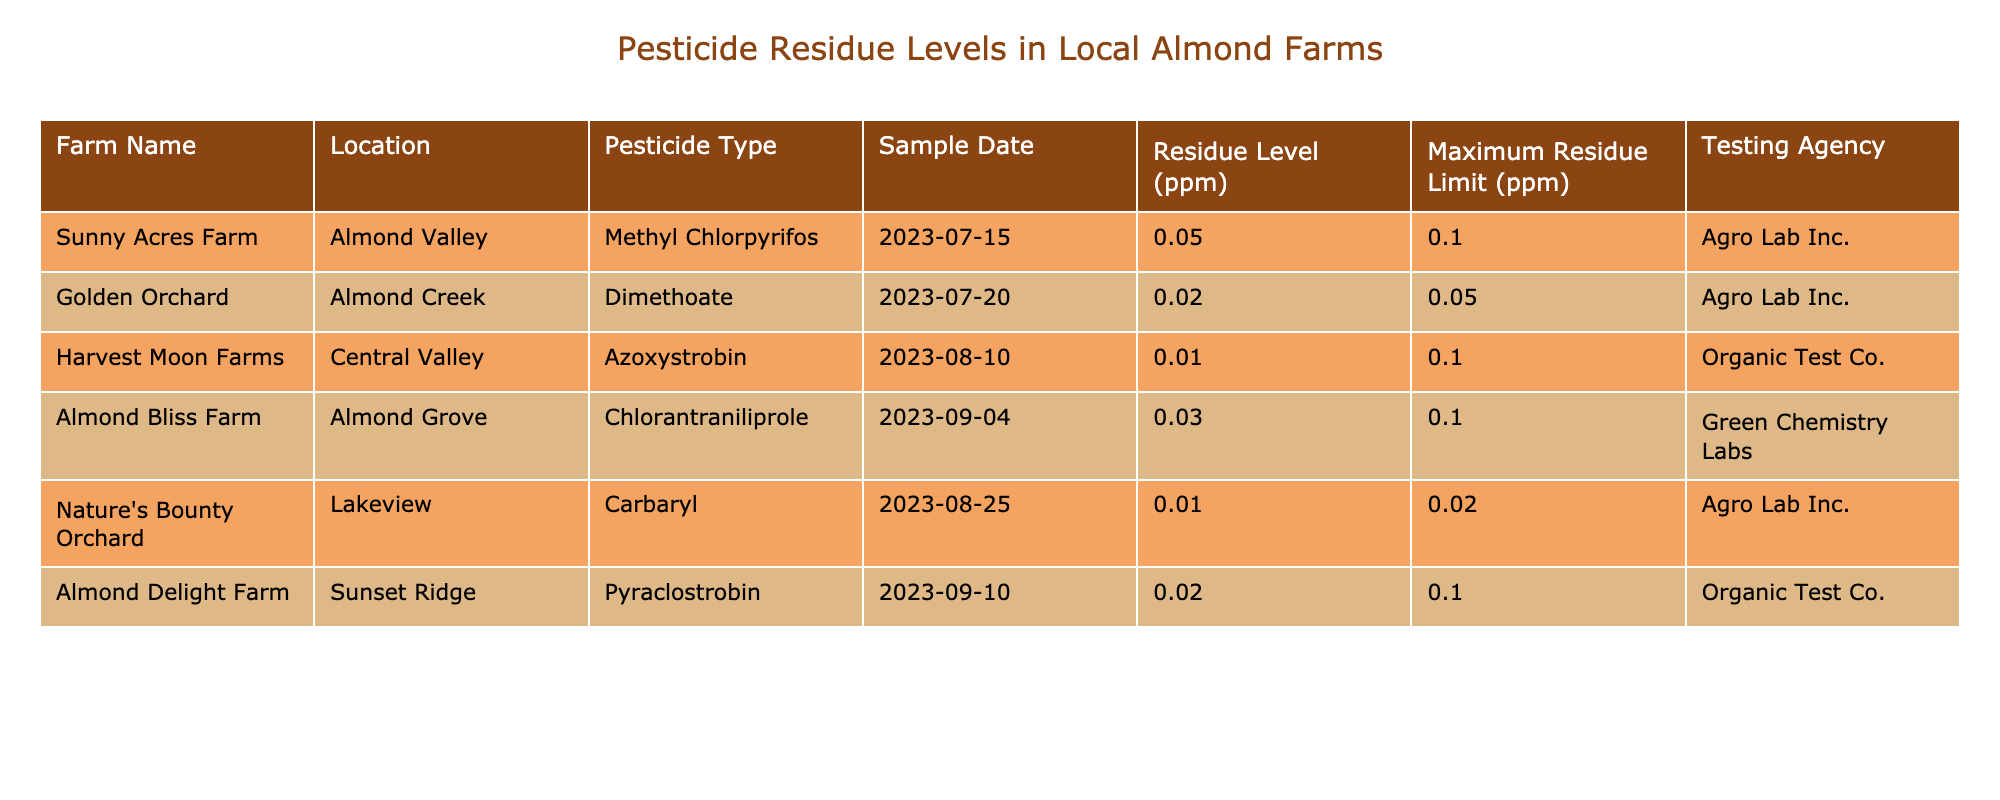What is the maximum residue limit for Dimethoate? Looking at the entry for Dimethoate under Pesticide Type, the Maximum Residue Limit (ppm) is listed as 0.05.
Answer: 0.05 Which farm has the highest pesticide residue level? Comparing all the residue levels listed in the table, Sunny Acres Farm has the highest level at 0.05 ppm.
Answer: Sunny Acres Farm Is the residue level at Nature's Bounty Orchard above the maximum residue limit? The residue level for Nature's Bounty Orchard is 0.01 ppm, which is below the Maximum Residue Limit of 0.02 ppm. Therefore, it is not above the limit.
Answer: No What is the average pesticide residue level across all the farms? Adding the residue levels: 0.05 + 0.02 + 0.01 + 0.03 + 0.01 + 0.02 = 0.14 ppm. There are 6 data points, so the average is 0.14/6 = 0.0233 ppm.
Answer: 0.0233 Did any farms exceed the maximum residue limits? By comparing each farm's residue level to its Maximum Residue Limit, all farms are below their respective limits, so none have exceeded the limits.
Answer: No What is the residue level of Chlorantraniliprole at Almond Bliss Farm? Referring to the entry for Almond Bliss Farm, the residue level for Chlorantraniliprole is 0.03 ppm.
Answer: 0.03 How many farms tested for pesticide residues in August 2023? There are two farms that tested in August 2023: Harvest Moon Farms on August 10 and Nature's Bounty Orchard on August 25.
Answer: 2 What is the difference between the maximum residue limit for Carbaryl and the residue level found at Nature's Bounty Orchard? The maximum residue limit for Carbaryl is 0.02 ppm, and the residue level at Nature's Bounty Orchard is 0.01 ppm. The difference is 0.02 - 0.01 = 0.01 ppm.
Answer: 0.01 